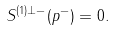Convert formula to latex. <formula><loc_0><loc_0><loc_500><loc_500>S ^ { ( 1 ) \perp - } ( p ^ { - } ) = 0 .</formula> 